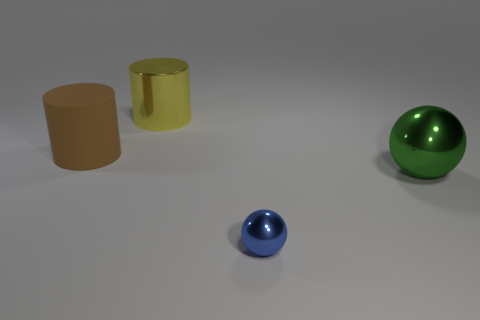Add 1 blue metal balls. How many objects exist? 5 Add 4 big shiny spheres. How many big shiny spheres are left? 5 Add 3 brown cylinders. How many brown cylinders exist? 4 Subtract 0 gray cylinders. How many objects are left? 4 Subtract all large yellow cylinders. Subtract all tiny things. How many objects are left? 2 